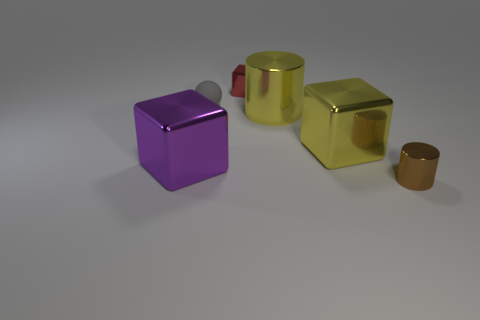Is there anything else that is the same shape as the rubber thing?
Provide a succinct answer. No. What number of big metallic cylinders are in front of the matte ball?
Provide a short and direct response. 1. Are there any purple cubes that have the same material as the gray object?
Provide a succinct answer. No. There is a gray ball that is the same size as the red object; what is it made of?
Provide a succinct answer. Rubber. Do the big cylinder and the brown thing have the same material?
Make the answer very short. Yes. How many objects are small matte objects or purple things?
Provide a succinct answer. 2. There is a small metal thing that is in front of the matte sphere; what is its shape?
Offer a terse response. Cylinder. There is a tiny cube that is the same material as the yellow cylinder; what color is it?
Your response must be concise. Red. What is the material of the other object that is the same shape as the brown shiny object?
Provide a succinct answer. Metal. What shape is the red object?
Provide a short and direct response. Cube. 